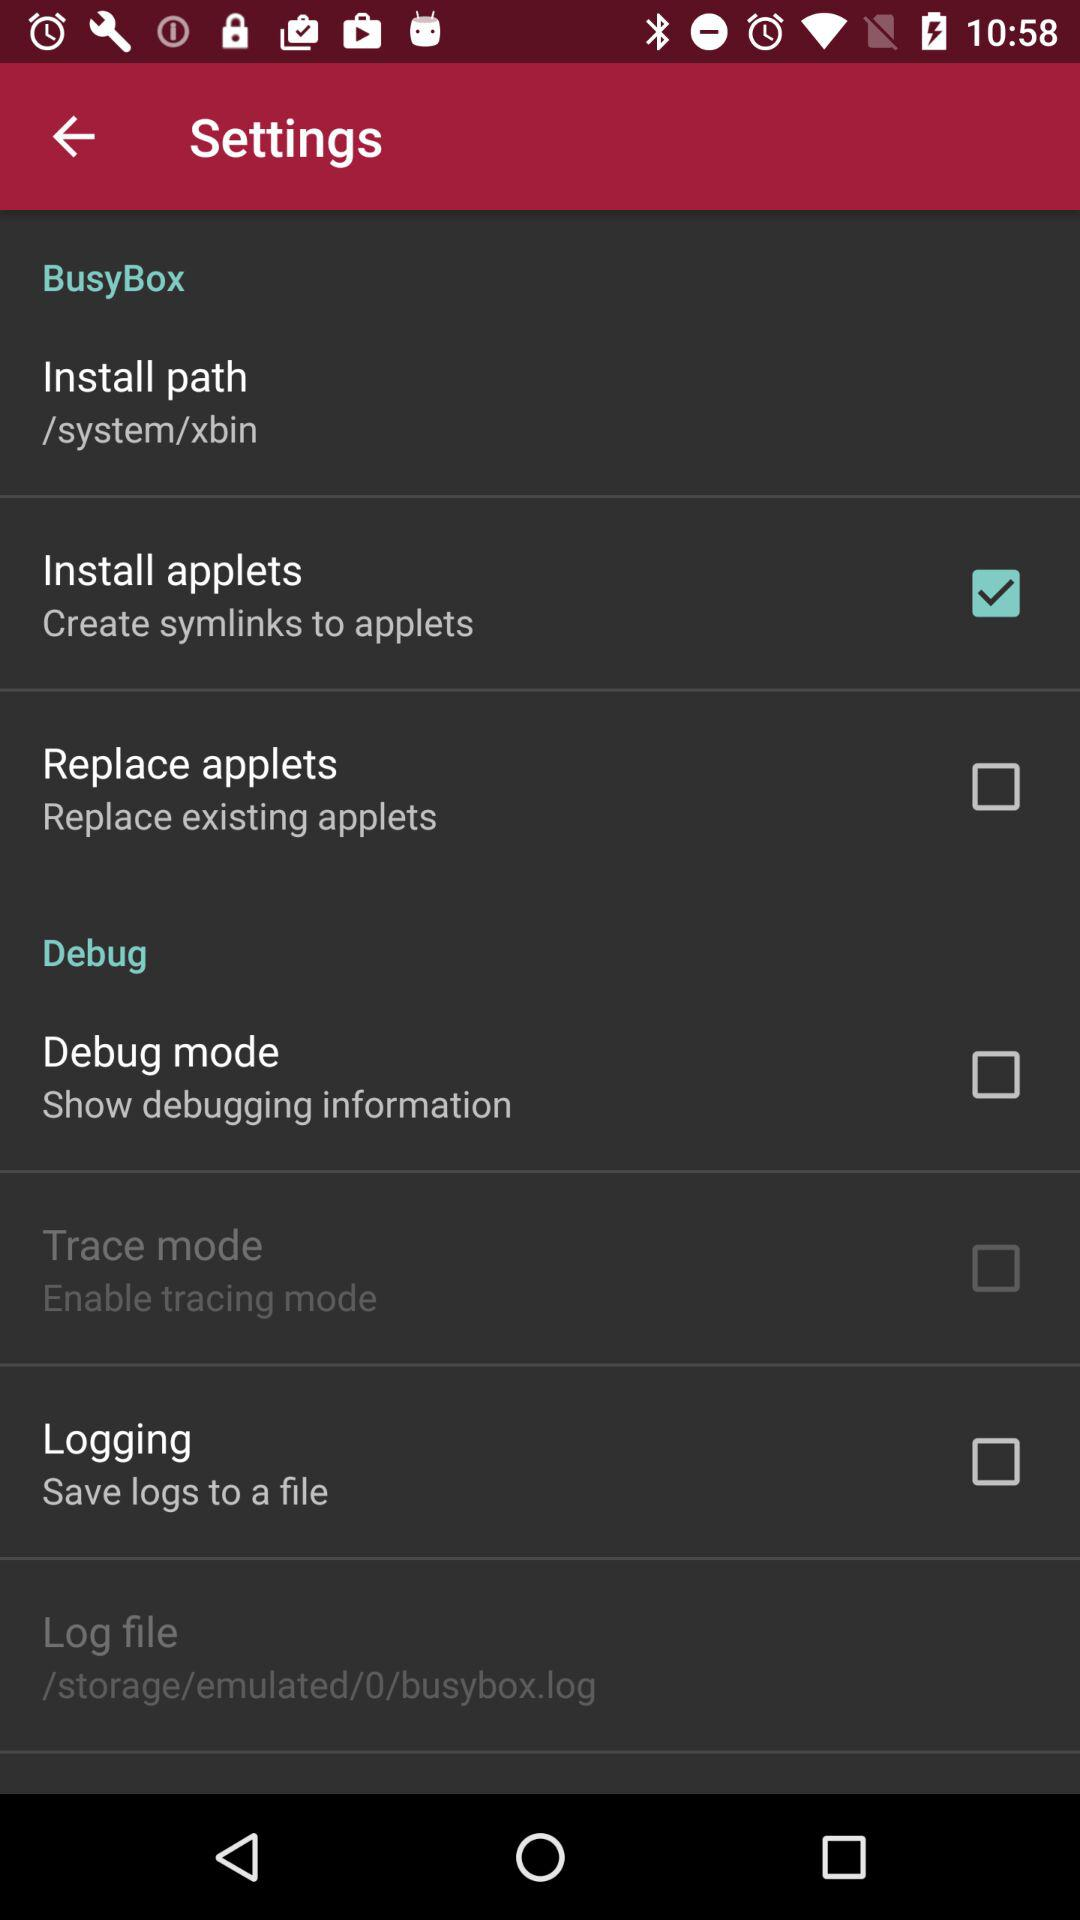Which setting option should we select to save logs to a file? The setting option that you should select to save logs to a file is "Logging". 